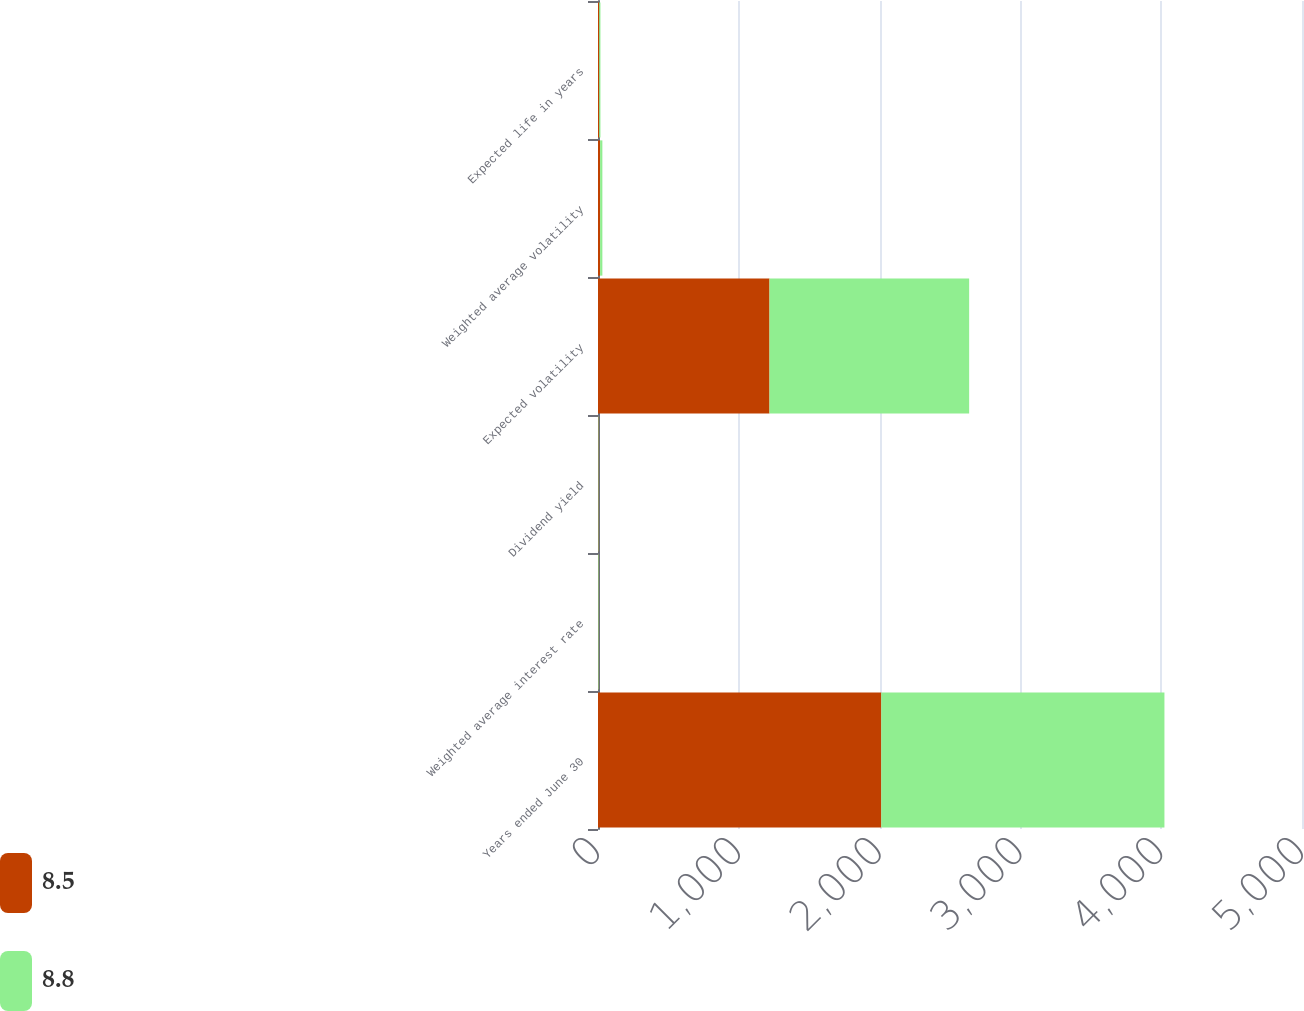<chart> <loc_0><loc_0><loc_500><loc_500><stacked_bar_chart><ecel><fcel>Years ended June 30<fcel>Weighted average interest rate<fcel>Dividend yield<fcel>Expected volatility<fcel>Weighted average volatility<fcel>Expected life in years<nl><fcel>8.5<fcel>2012<fcel>1.9<fcel>2.6<fcel>1218<fcel>15<fcel>8.5<nl><fcel>8.8<fcel>2011<fcel>3.4<fcel>2.4<fcel>1418<fcel>16<fcel>8.8<nl></chart> 